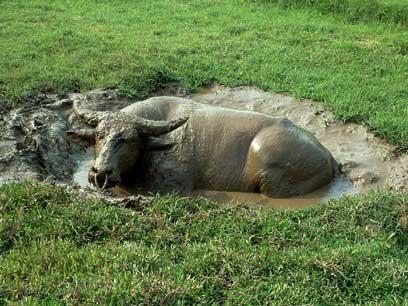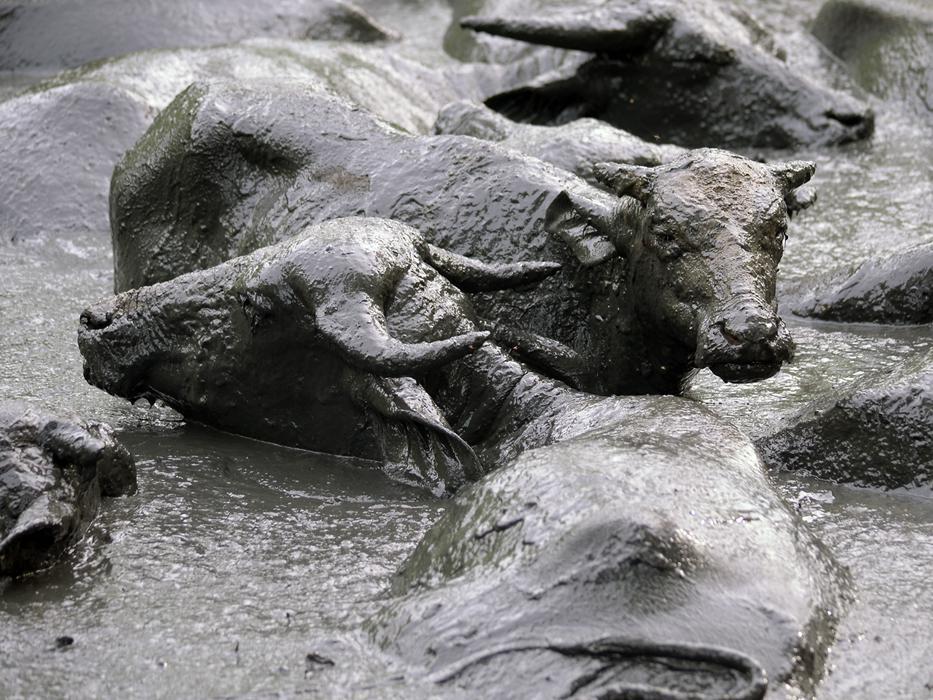The first image is the image on the left, the second image is the image on the right. Given the left and right images, does the statement "There are at least four adult buffalos having a mud bath." hold true? Answer yes or no. Yes. The first image is the image on the left, the second image is the image on the right. Examine the images to the left and right. Is the description "An image shows exactly one water buffalo in a muddy pit, with its head turned forward." accurate? Answer yes or no. Yes. 